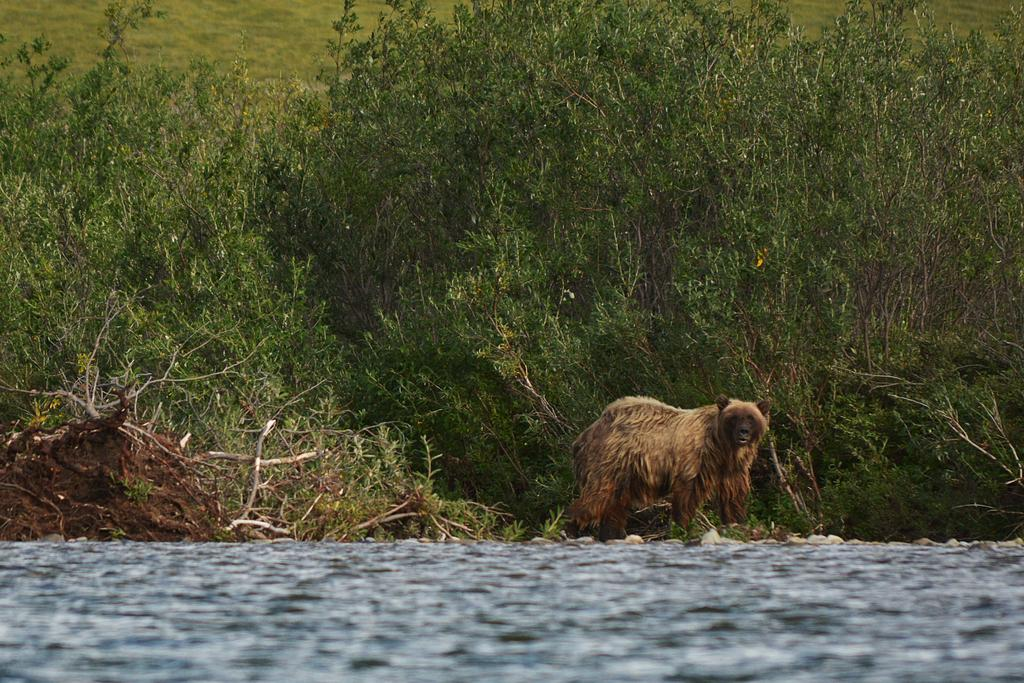What type of animal is in the image? The type of animal cannot be determined from the provided facts. What natural elements are present in the image? Trees, grass, soil, and water are present in the image. Can you describe the environment in the image? The environment in the image includes trees, grass, soil, and water, suggesting a natural setting. How many dimes are scattered on the grass in the image? There is no mention of dimes in the provided facts, so it cannot be determined if any are present in the image. 